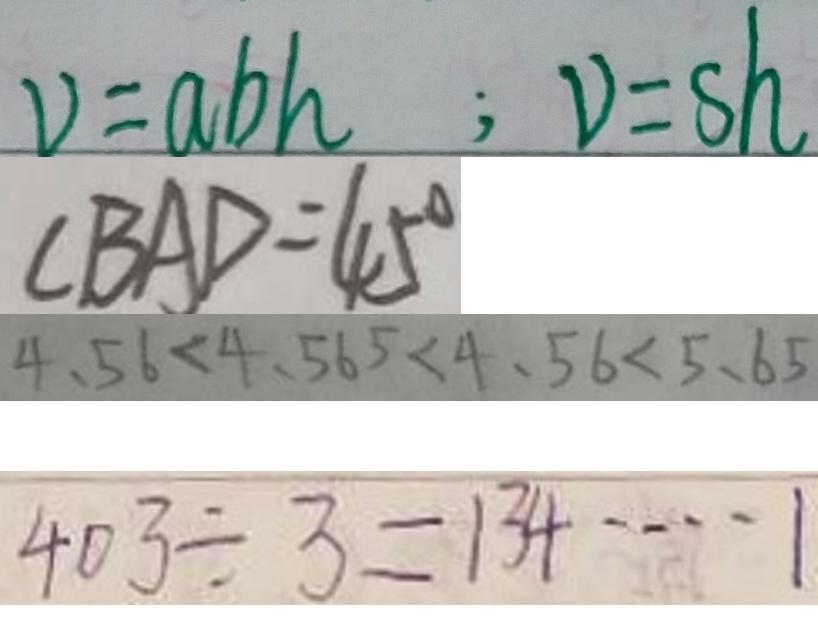<formula> <loc_0><loc_0><loc_500><loc_500>V = a b h ; V = s h 
 \angle B A D = 4 5 ^ { \circ } 
 4 . 5 6 < 4 . 5 6 5 < 4 . 5 6 < 5 . 6 5 
 4 0 3 \div 3 = 1 3 4 \cdots 1</formula> 